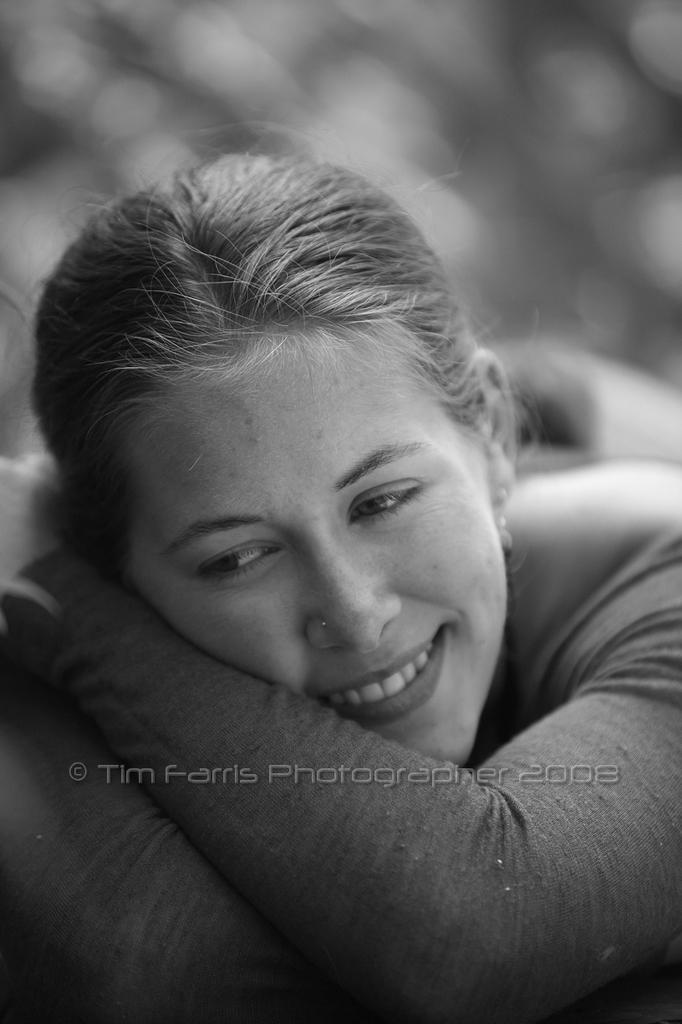What is the color scheme of the image? The image is in black and white. Who is present in the image? There is a woman in the image. What expression does the woman have? The woman is smiling. Can you describe the background of the image? The background of the image is blurred. Is there any text or logo visible in the image? Yes, there is a watermark at the bottom of the image. What type of vegetable is being knitted with wool in the image? There is no vegetable or wool present in the image; it features a woman with a blurred background and a watermark. 